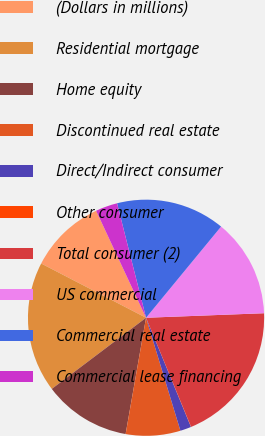Convert chart to OTSL. <chart><loc_0><loc_0><loc_500><loc_500><pie_chart><fcel>(Dollars in millions)<fcel>Residential mortgage<fcel>Home equity<fcel>Discontinued real estate<fcel>Direct/Indirect consumer<fcel>Other consumer<fcel>Total consumer (2)<fcel>US commercial<fcel>Commercial real estate<fcel>Commercial lease financing<nl><fcel>10.45%<fcel>17.89%<fcel>11.94%<fcel>7.47%<fcel>1.51%<fcel>0.02%<fcel>19.38%<fcel>13.43%<fcel>14.91%<fcel>3.0%<nl></chart> 